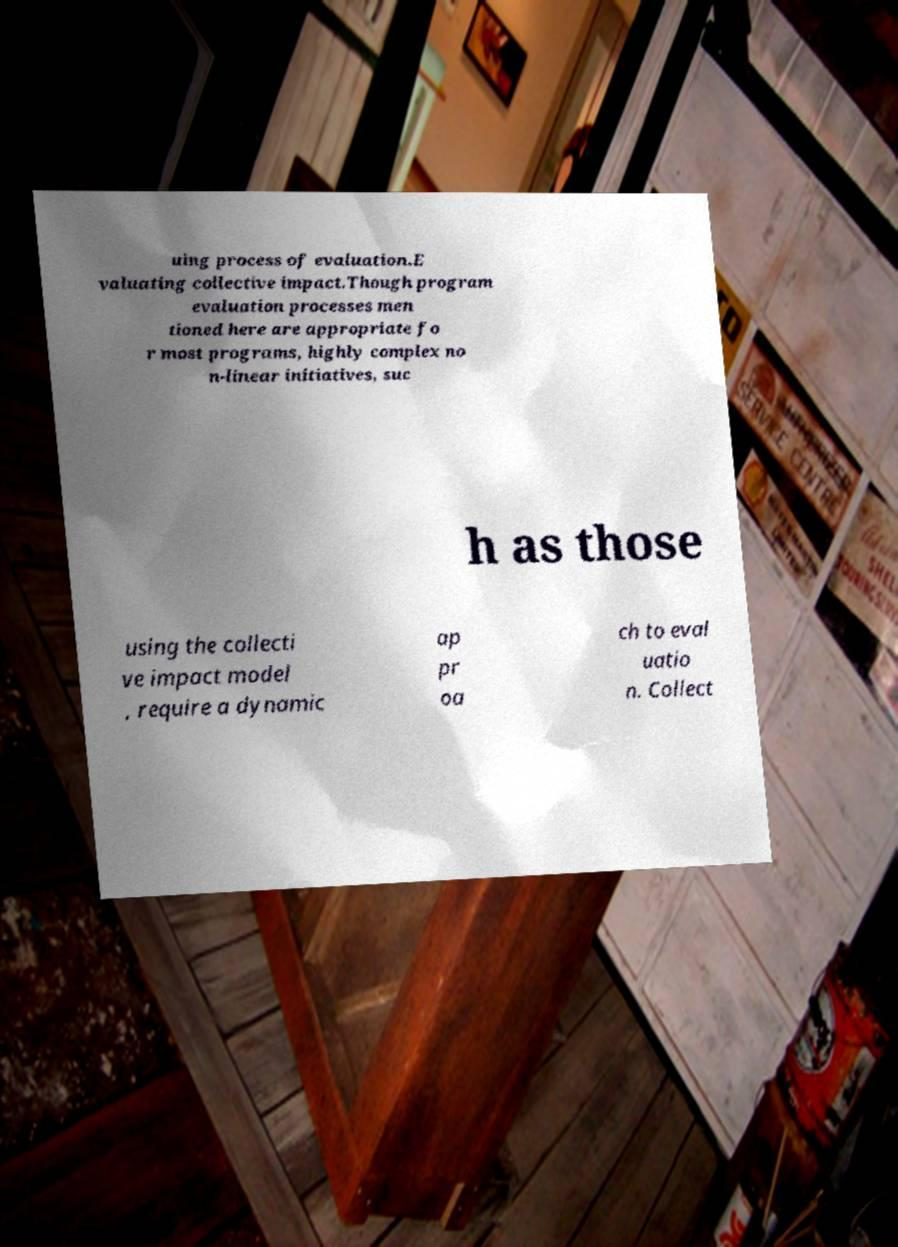Could you assist in decoding the text presented in this image and type it out clearly? uing process of evaluation.E valuating collective impact.Though program evaluation processes men tioned here are appropriate fo r most programs, highly complex no n-linear initiatives, suc h as those using the collecti ve impact model , require a dynamic ap pr oa ch to eval uatio n. Collect 